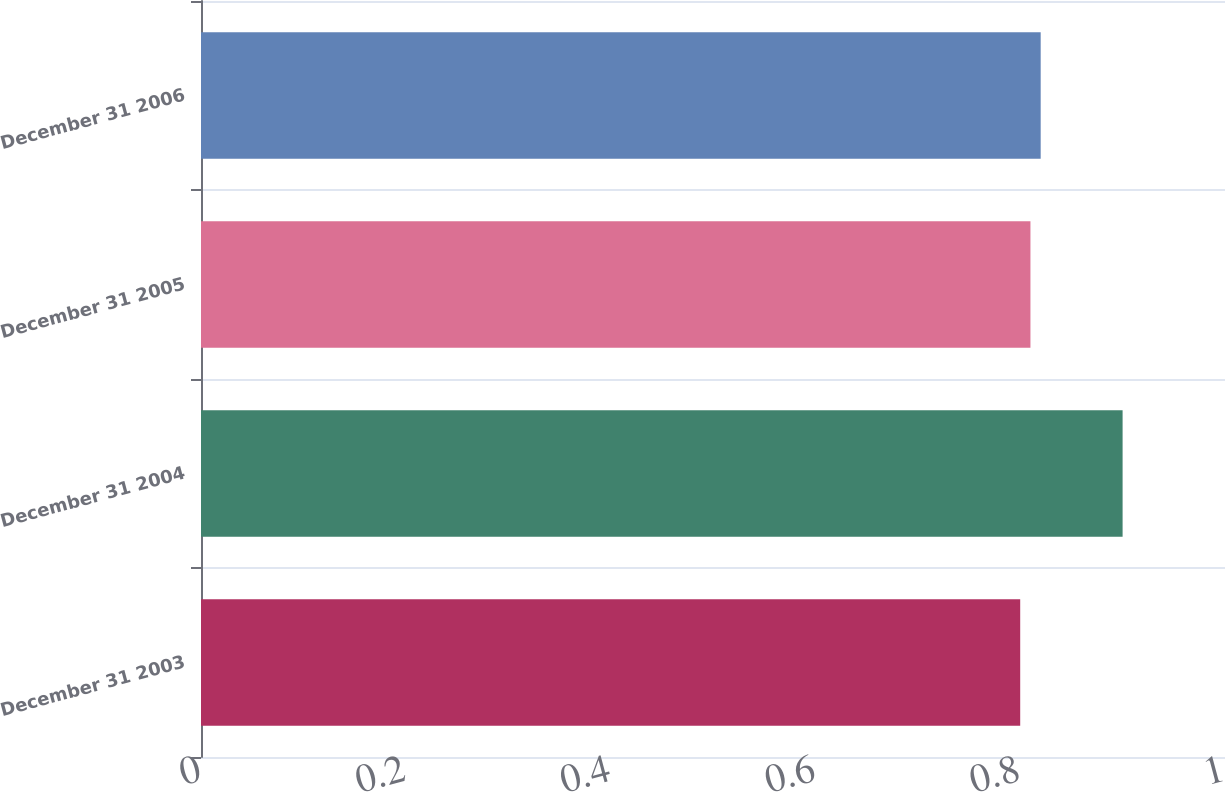Convert chart to OTSL. <chart><loc_0><loc_0><loc_500><loc_500><bar_chart><fcel>December 31 2003<fcel>December 31 2004<fcel>December 31 2005<fcel>December 31 2006<nl><fcel>0.8<fcel>0.9<fcel>0.81<fcel>0.82<nl></chart> 